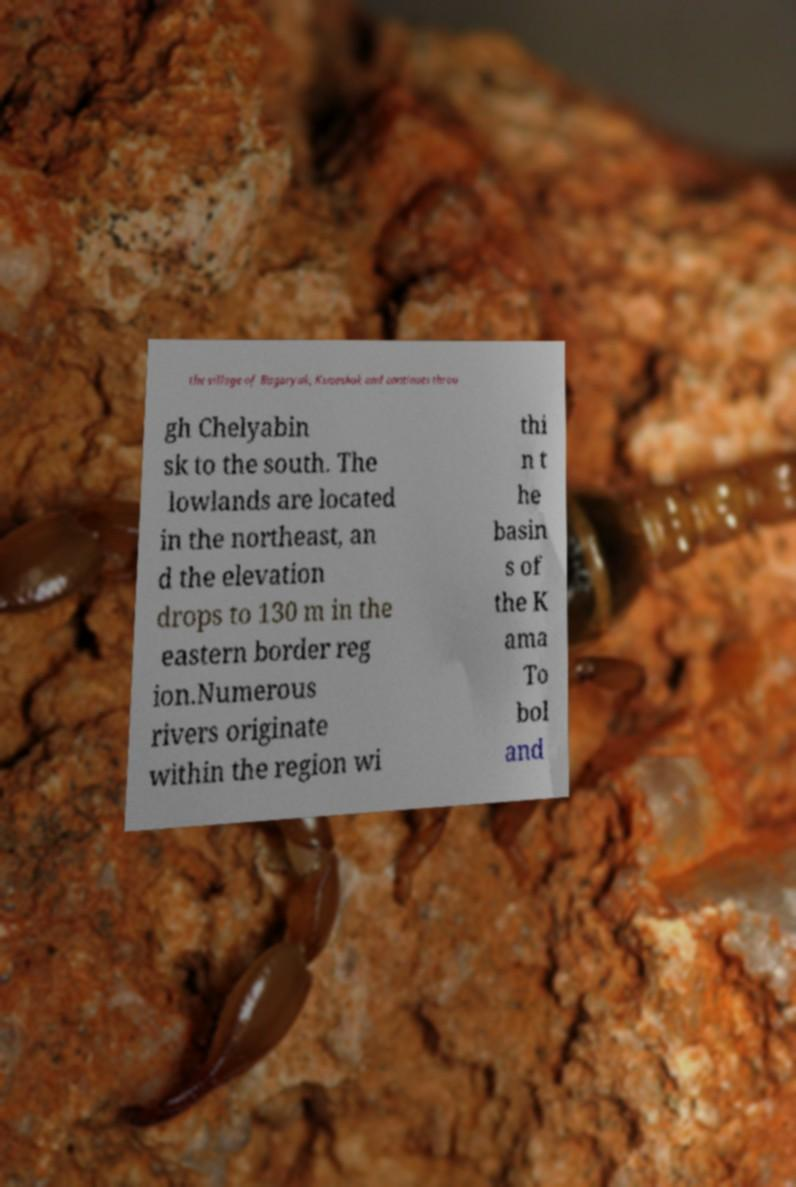Could you assist in decoding the text presented in this image and type it out clearly? the village of Bagaryak, Kunashak and continues throu gh Chelyabin sk to the south. The lowlands are located in the northeast, an d the elevation drops to 130 m in the eastern border reg ion.Numerous rivers originate within the region wi thi n t he basin s of the K ama To bol and 